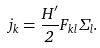<formula> <loc_0><loc_0><loc_500><loc_500>j _ { k } = \frac { H ^ { \prime } } { 2 } F _ { k l } \Sigma _ { l } .</formula> 